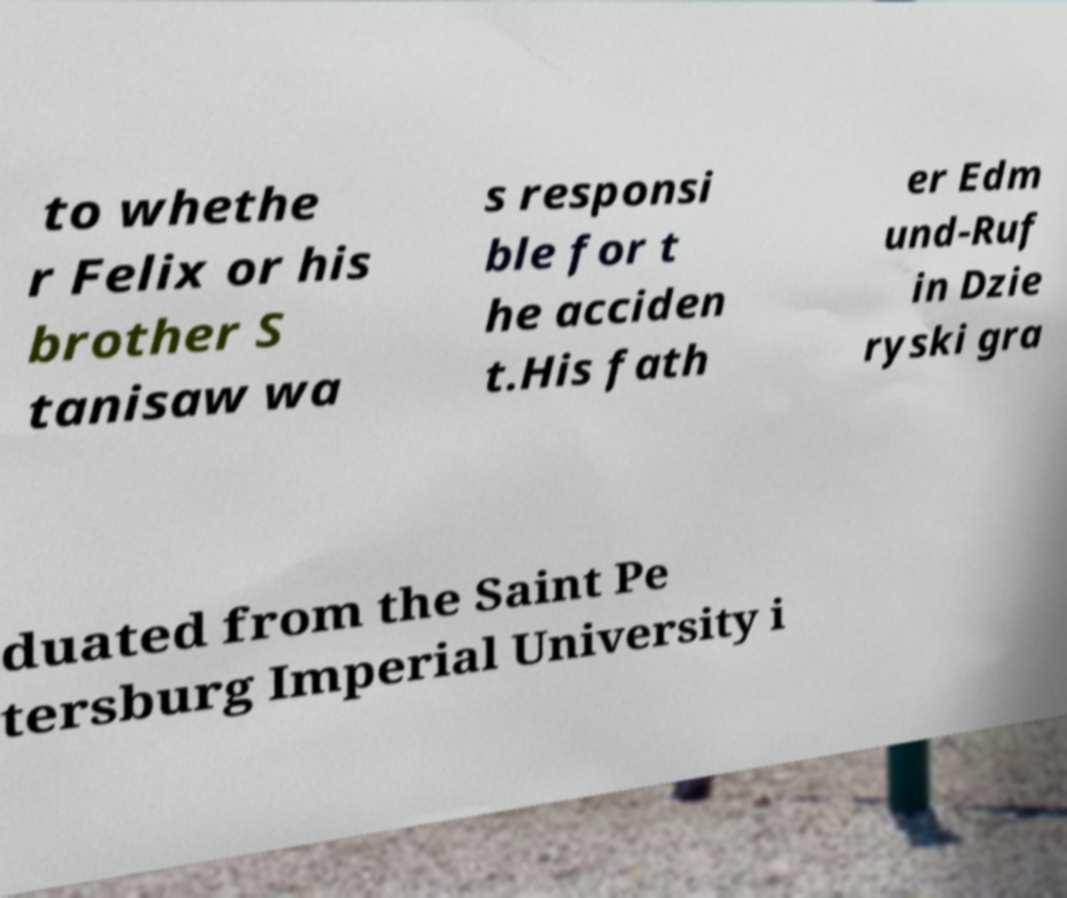There's text embedded in this image that I need extracted. Can you transcribe it verbatim? to whethe r Felix or his brother S tanisaw wa s responsi ble for t he acciden t.His fath er Edm und-Ruf in Dzie ryski gra duated from the Saint Pe tersburg Imperial University i 